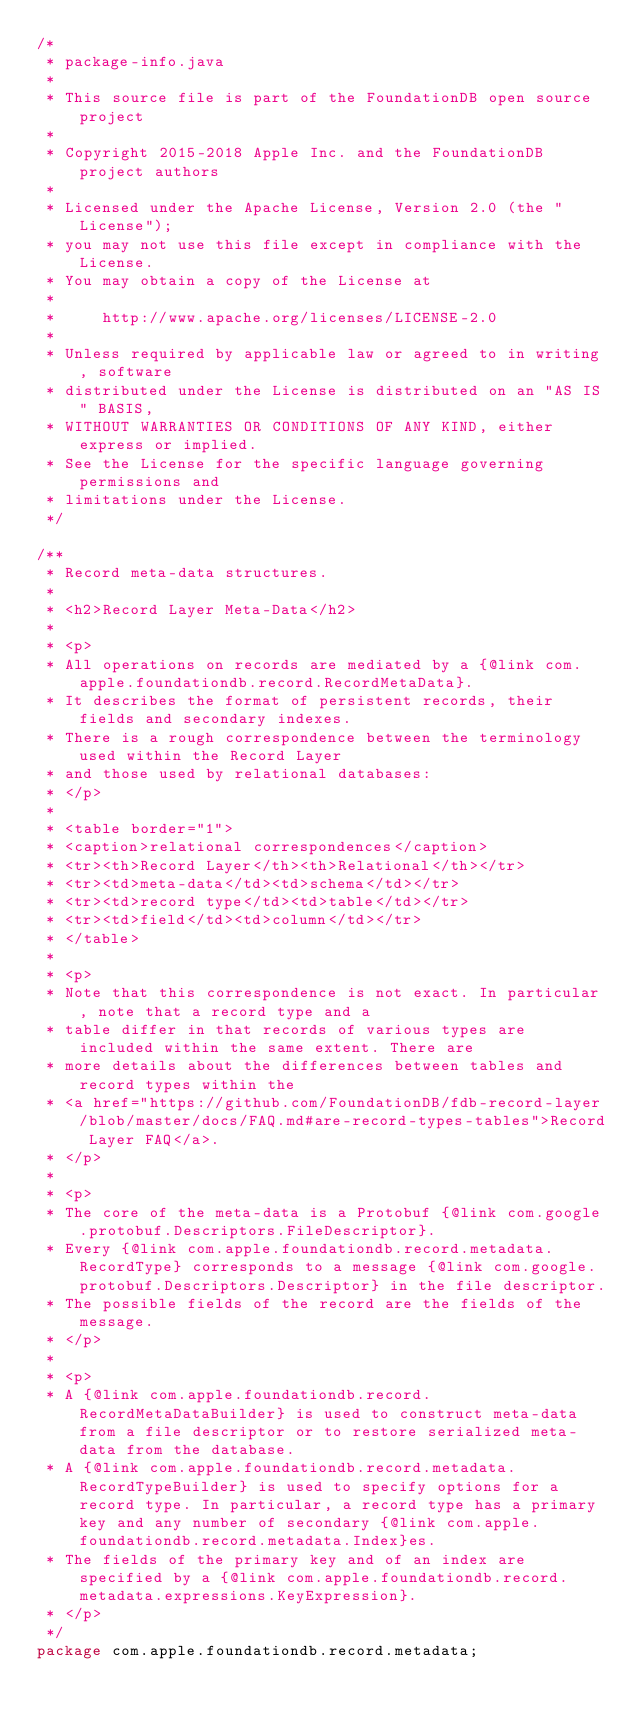Convert code to text. <code><loc_0><loc_0><loc_500><loc_500><_Java_>/*
 * package-info.java
 *
 * This source file is part of the FoundationDB open source project
 *
 * Copyright 2015-2018 Apple Inc. and the FoundationDB project authors
 *
 * Licensed under the Apache License, Version 2.0 (the "License");
 * you may not use this file except in compliance with the License.
 * You may obtain a copy of the License at
 *
 *     http://www.apache.org/licenses/LICENSE-2.0
 *
 * Unless required by applicable law or agreed to in writing, software
 * distributed under the License is distributed on an "AS IS" BASIS,
 * WITHOUT WARRANTIES OR CONDITIONS OF ANY KIND, either express or implied.
 * See the License for the specific language governing permissions and
 * limitations under the License.
 */

/**
 * Record meta-data structures.
 *
 * <h2>Record Layer Meta-Data</h2>
 *
 * <p>
 * All operations on records are mediated by a {@link com.apple.foundationdb.record.RecordMetaData}.
 * It describes the format of persistent records, their fields and secondary indexes.
 * There is a rough correspondence between the terminology used within the Record Layer
 * and those used by relational databases:
 * </p>
 *
 * <table border="1">
 * <caption>relational correspondences</caption>
 * <tr><th>Record Layer</th><th>Relational</th></tr>
 * <tr><td>meta-data</td><td>schema</td></tr>
 * <tr><td>record type</td><td>table</td></tr>
 * <tr><td>field</td><td>column</td></tr>
 * </table>
 *
 * <p>
 * Note that this correspondence is not exact. In particular, note that a record type and a
 * table differ in that records of various types are included within the same extent. There are
 * more details about the differences between tables and record types within the
 * <a href="https://github.com/FoundationDB/fdb-record-layer/blob/master/docs/FAQ.md#are-record-types-tables">Record Layer FAQ</a>.
 * </p>
 *
 * <p>
 * The core of the meta-data is a Protobuf {@link com.google.protobuf.Descriptors.FileDescriptor}.
 * Every {@link com.apple.foundationdb.record.metadata.RecordType} corresponds to a message {@link com.google.protobuf.Descriptors.Descriptor} in the file descriptor.
 * The possible fields of the record are the fields of the message.
 * </p>
 *
 * <p>
 * A {@link com.apple.foundationdb.record.RecordMetaDataBuilder} is used to construct meta-data from a file descriptor or to restore serialized meta-data from the database.
 * A {@link com.apple.foundationdb.record.metadata.RecordTypeBuilder} is used to specify options for a record type. In particular, a record type has a primary key and any number of secondary {@link com.apple.foundationdb.record.metadata.Index}es.
 * The fields of the primary key and of an index are specified by a {@link com.apple.foundationdb.record.metadata.expressions.KeyExpression}.
 * </p>
 */
package com.apple.foundationdb.record.metadata;
</code> 